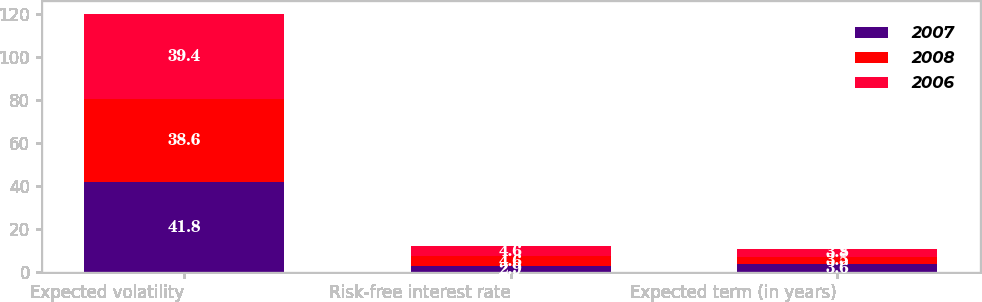Convert chart to OTSL. <chart><loc_0><loc_0><loc_500><loc_500><stacked_bar_chart><ecel><fcel>Expected volatility<fcel>Risk-free interest rate<fcel>Expected term (in years)<nl><fcel>2007<fcel>41.8<fcel>2.9<fcel>3.6<nl><fcel>2008<fcel>38.6<fcel>4.6<fcel>3.5<nl><fcel>2006<fcel>39.4<fcel>4.6<fcel>3.8<nl></chart> 